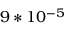Convert formula to latex. <formula><loc_0><loc_0><loc_500><loc_500>9 * 1 0 ^ { - 5 }</formula> 